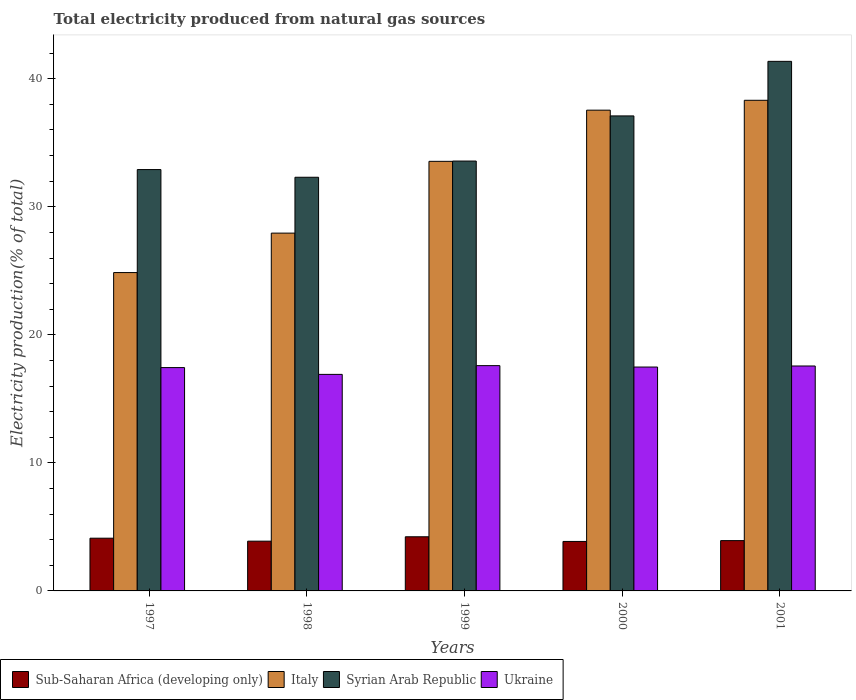How many different coloured bars are there?
Make the answer very short. 4. Are the number of bars per tick equal to the number of legend labels?
Your response must be concise. Yes. Are the number of bars on each tick of the X-axis equal?
Make the answer very short. Yes. In how many cases, is the number of bars for a given year not equal to the number of legend labels?
Provide a short and direct response. 0. What is the total electricity produced in Sub-Saharan Africa (developing only) in 2001?
Provide a short and direct response. 3.93. Across all years, what is the maximum total electricity produced in Syrian Arab Republic?
Offer a very short reply. 41.36. Across all years, what is the minimum total electricity produced in Sub-Saharan Africa (developing only)?
Ensure brevity in your answer.  3.86. In which year was the total electricity produced in Sub-Saharan Africa (developing only) maximum?
Your response must be concise. 1999. What is the total total electricity produced in Ukraine in the graph?
Give a very brief answer. 87. What is the difference between the total electricity produced in Ukraine in 1998 and that in 2001?
Provide a short and direct response. -0.66. What is the difference between the total electricity produced in Syrian Arab Republic in 1998 and the total electricity produced in Ukraine in 2001?
Offer a very short reply. 14.74. What is the average total electricity produced in Syrian Arab Republic per year?
Give a very brief answer. 35.45. In the year 2000, what is the difference between the total electricity produced in Sub-Saharan Africa (developing only) and total electricity produced in Italy?
Offer a very short reply. -33.68. What is the ratio of the total electricity produced in Syrian Arab Republic in 1999 to that in 2001?
Provide a succinct answer. 0.81. Is the difference between the total electricity produced in Sub-Saharan Africa (developing only) in 1997 and 2001 greater than the difference between the total electricity produced in Italy in 1997 and 2001?
Ensure brevity in your answer.  Yes. What is the difference between the highest and the second highest total electricity produced in Ukraine?
Make the answer very short. 0.03. What is the difference between the highest and the lowest total electricity produced in Ukraine?
Your answer should be very brief. 0.68. In how many years, is the total electricity produced in Italy greater than the average total electricity produced in Italy taken over all years?
Your answer should be very brief. 3. Is the sum of the total electricity produced in Italy in 1997 and 1998 greater than the maximum total electricity produced in Ukraine across all years?
Provide a short and direct response. Yes. Is it the case that in every year, the sum of the total electricity produced in Ukraine and total electricity produced in Syrian Arab Republic is greater than the sum of total electricity produced in Sub-Saharan Africa (developing only) and total electricity produced in Italy?
Keep it short and to the point. No. What does the 3rd bar from the right in 1997 represents?
Give a very brief answer. Italy. Is it the case that in every year, the sum of the total electricity produced in Italy and total electricity produced in Sub-Saharan Africa (developing only) is greater than the total electricity produced in Ukraine?
Keep it short and to the point. Yes. How many bars are there?
Give a very brief answer. 20. Are all the bars in the graph horizontal?
Offer a terse response. No. Are the values on the major ticks of Y-axis written in scientific E-notation?
Ensure brevity in your answer.  No. Does the graph contain any zero values?
Your response must be concise. No. Where does the legend appear in the graph?
Offer a very short reply. Bottom left. How many legend labels are there?
Give a very brief answer. 4. How are the legend labels stacked?
Provide a succinct answer. Horizontal. What is the title of the graph?
Give a very brief answer. Total electricity produced from natural gas sources. Does "Rwanda" appear as one of the legend labels in the graph?
Your response must be concise. No. What is the label or title of the Y-axis?
Make the answer very short. Electricity production(% of total). What is the Electricity production(% of total) of Sub-Saharan Africa (developing only) in 1997?
Ensure brevity in your answer.  4.12. What is the Electricity production(% of total) in Italy in 1997?
Make the answer very short. 24.86. What is the Electricity production(% of total) in Syrian Arab Republic in 1997?
Your response must be concise. 32.91. What is the Electricity production(% of total) of Ukraine in 1997?
Your answer should be very brief. 17.44. What is the Electricity production(% of total) of Sub-Saharan Africa (developing only) in 1998?
Provide a succinct answer. 3.89. What is the Electricity production(% of total) in Italy in 1998?
Offer a very short reply. 27.94. What is the Electricity production(% of total) in Syrian Arab Republic in 1998?
Offer a very short reply. 32.31. What is the Electricity production(% of total) in Ukraine in 1998?
Give a very brief answer. 16.91. What is the Electricity production(% of total) in Sub-Saharan Africa (developing only) in 1999?
Provide a short and direct response. 4.23. What is the Electricity production(% of total) in Italy in 1999?
Provide a short and direct response. 33.55. What is the Electricity production(% of total) of Syrian Arab Republic in 1999?
Your answer should be very brief. 33.57. What is the Electricity production(% of total) in Ukraine in 1999?
Provide a short and direct response. 17.6. What is the Electricity production(% of total) in Sub-Saharan Africa (developing only) in 2000?
Give a very brief answer. 3.86. What is the Electricity production(% of total) of Italy in 2000?
Provide a short and direct response. 37.55. What is the Electricity production(% of total) of Syrian Arab Republic in 2000?
Provide a succinct answer. 37.1. What is the Electricity production(% of total) of Ukraine in 2000?
Give a very brief answer. 17.49. What is the Electricity production(% of total) of Sub-Saharan Africa (developing only) in 2001?
Make the answer very short. 3.93. What is the Electricity production(% of total) of Italy in 2001?
Keep it short and to the point. 38.32. What is the Electricity production(% of total) of Syrian Arab Republic in 2001?
Offer a terse response. 41.36. What is the Electricity production(% of total) of Ukraine in 2001?
Make the answer very short. 17.57. Across all years, what is the maximum Electricity production(% of total) in Sub-Saharan Africa (developing only)?
Your response must be concise. 4.23. Across all years, what is the maximum Electricity production(% of total) of Italy?
Your response must be concise. 38.32. Across all years, what is the maximum Electricity production(% of total) in Syrian Arab Republic?
Your answer should be compact. 41.36. Across all years, what is the maximum Electricity production(% of total) in Ukraine?
Your answer should be compact. 17.6. Across all years, what is the minimum Electricity production(% of total) of Sub-Saharan Africa (developing only)?
Your answer should be compact. 3.86. Across all years, what is the minimum Electricity production(% of total) of Italy?
Provide a succinct answer. 24.86. Across all years, what is the minimum Electricity production(% of total) of Syrian Arab Republic?
Provide a succinct answer. 32.31. Across all years, what is the minimum Electricity production(% of total) of Ukraine?
Offer a terse response. 16.91. What is the total Electricity production(% of total) of Sub-Saharan Africa (developing only) in the graph?
Your answer should be compact. 20.03. What is the total Electricity production(% of total) of Italy in the graph?
Give a very brief answer. 162.23. What is the total Electricity production(% of total) of Syrian Arab Republic in the graph?
Your answer should be very brief. 177.25. What is the total Electricity production(% of total) in Ukraine in the graph?
Your response must be concise. 87. What is the difference between the Electricity production(% of total) of Sub-Saharan Africa (developing only) in 1997 and that in 1998?
Your answer should be compact. 0.23. What is the difference between the Electricity production(% of total) in Italy in 1997 and that in 1998?
Offer a terse response. -3.08. What is the difference between the Electricity production(% of total) in Syrian Arab Republic in 1997 and that in 1998?
Keep it short and to the point. 0.6. What is the difference between the Electricity production(% of total) in Ukraine in 1997 and that in 1998?
Offer a very short reply. 0.53. What is the difference between the Electricity production(% of total) in Sub-Saharan Africa (developing only) in 1997 and that in 1999?
Give a very brief answer. -0.11. What is the difference between the Electricity production(% of total) of Italy in 1997 and that in 1999?
Provide a short and direct response. -8.69. What is the difference between the Electricity production(% of total) of Syrian Arab Republic in 1997 and that in 1999?
Your answer should be very brief. -0.66. What is the difference between the Electricity production(% of total) of Ukraine in 1997 and that in 1999?
Offer a terse response. -0.15. What is the difference between the Electricity production(% of total) in Sub-Saharan Africa (developing only) in 1997 and that in 2000?
Give a very brief answer. 0.25. What is the difference between the Electricity production(% of total) of Italy in 1997 and that in 2000?
Your response must be concise. -12.68. What is the difference between the Electricity production(% of total) in Syrian Arab Republic in 1997 and that in 2000?
Offer a terse response. -4.19. What is the difference between the Electricity production(% of total) of Ukraine in 1997 and that in 2000?
Offer a terse response. -0.04. What is the difference between the Electricity production(% of total) of Sub-Saharan Africa (developing only) in 1997 and that in 2001?
Your answer should be compact. 0.19. What is the difference between the Electricity production(% of total) in Italy in 1997 and that in 2001?
Provide a short and direct response. -13.46. What is the difference between the Electricity production(% of total) in Syrian Arab Republic in 1997 and that in 2001?
Offer a terse response. -8.45. What is the difference between the Electricity production(% of total) of Ukraine in 1997 and that in 2001?
Provide a short and direct response. -0.13. What is the difference between the Electricity production(% of total) in Sub-Saharan Africa (developing only) in 1998 and that in 1999?
Provide a short and direct response. -0.34. What is the difference between the Electricity production(% of total) in Italy in 1998 and that in 1999?
Offer a terse response. -5.61. What is the difference between the Electricity production(% of total) of Syrian Arab Republic in 1998 and that in 1999?
Provide a short and direct response. -1.27. What is the difference between the Electricity production(% of total) of Ukraine in 1998 and that in 1999?
Your answer should be very brief. -0.68. What is the difference between the Electricity production(% of total) of Sub-Saharan Africa (developing only) in 1998 and that in 2000?
Make the answer very short. 0.02. What is the difference between the Electricity production(% of total) of Italy in 1998 and that in 2000?
Keep it short and to the point. -9.6. What is the difference between the Electricity production(% of total) in Syrian Arab Republic in 1998 and that in 2000?
Give a very brief answer. -4.79. What is the difference between the Electricity production(% of total) of Ukraine in 1998 and that in 2000?
Your response must be concise. -0.57. What is the difference between the Electricity production(% of total) of Sub-Saharan Africa (developing only) in 1998 and that in 2001?
Ensure brevity in your answer.  -0.04. What is the difference between the Electricity production(% of total) of Italy in 1998 and that in 2001?
Provide a short and direct response. -10.37. What is the difference between the Electricity production(% of total) of Syrian Arab Republic in 1998 and that in 2001?
Your response must be concise. -9.05. What is the difference between the Electricity production(% of total) of Ukraine in 1998 and that in 2001?
Ensure brevity in your answer.  -0.66. What is the difference between the Electricity production(% of total) in Sub-Saharan Africa (developing only) in 1999 and that in 2000?
Provide a short and direct response. 0.37. What is the difference between the Electricity production(% of total) in Italy in 1999 and that in 2000?
Your response must be concise. -4. What is the difference between the Electricity production(% of total) of Syrian Arab Republic in 1999 and that in 2000?
Keep it short and to the point. -3.53. What is the difference between the Electricity production(% of total) of Ukraine in 1999 and that in 2000?
Make the answer very short. 0.11. What is the difference between the Electricity production(% of total) of Sub-Saharan Africa (developing only) in 1999 and that in 2001?
Ensure brevity in your answer.  0.3. What is the difference between the Electricity production(% of total) in Italy in 1999 and that in 2001?
Provide a succinct answer. -4.77. What is the difference between the Electricity production(% of total) in Syrian Arab Republic in 1999 and that in 2001?
Your answer should be compact. -7.79. What is the difference between the Electricity production(% of total) in Ukraine in 1999 and that in 2001?
Make the answer very short. 0.03. What is the difference between the Electricity production(% of total) of Sub-Saharan Africa (developing only) in 2000 and that in 2001?
Offer a terse response. -0.07. What is the difference between the Electricity production(% of total) of Italy in 2000 and that in 2001?
Give a very brief answer. -0.77. What is the difference between the Electricity production(% of total) in Syrian Arab Republic in 2000 and that in 2001?
Your answer should be compact. -4.26. What is the difference between the Electricity production(% of total) in Ukraine in 2000 and that in 2001?
Make the answer very short. -0.08. What is the difference between the Electricity production(% of total) in Sub-Saharan Africa (developing only) in 1997 and the Electricity production(% of total) in Italy in 1998?
Provide a succinct answer. -23.83. What is the difference between the Electricity production(% of total) in Sub-Saharan Africa (developing only) in 1997 and the Electricity production(% of total) in Syrian Arab Republic in 1998?
Ensure brevity in your answer.  -28.19. What is the difference between the Electricity production(% of total) in Sub-Saharan Africa (developing only) in 1997 and the Electricity production(% of total) in Ukraine in 1998?
Your answer should be compact. -12.79. What is the difference between the Electricity production(% of total) of Italy in 1997 and the Electricity production(% of total) of Syrian Arab Republic in 1998?
Ensure brevity in your answer.  -7.44. What is the difference between the Electricity production(% of total) of Italy in 1997 and the Electricity production(% of total) of Ukraine in 1998?
Make the answer very short. 7.95. What is the difference between the Electricity production(% of total) in Syrian Arab Republic in 1997 and the Electricity production(% of total) in Ukraine in 1998?
Offer a terse response. 16. What is the difference between the Electricity production(% of total) in Sub-Saharan Africa (developing only) in 1997 and the Electricity production(% of total) in Italy in 1999?
Your answer should be compact. -29.43. What is the difference between the Electricity production(% of total) in Sub-Saharan Africa (developing only) in 1997 and the Electricity production(% of total) in Syrian Arab Republic in 1999?
Your response must be concise. -29.45. What is the difference between the Electricity production(% of total) in Sub-Saharan Africa (developing only) in 1997 and the Electricity production(% of total) in Ukraine in 1999?
Provide a short and direct response. -13.48. What is the difference between the Electricity production(% of total) in Italy in 1997 and the Electricity production(% of total) in Syrian Arab Republic in 1999?
Give a very brief answer. -8.71. What is the difference between the Electricity production(% of total) in Italy in 1997 and the Electricity production(% of total) in Ukraine in 1999?
Keep it short and to the point. 7.27. What is the difference between the Electricity production(% of total) of Syrian Arab Republic in 1997 and the Electricity production(% of total) of Ukraine in 1999?
Provide a short and direct response. 15.31. What is the difference between the Electricity production(% of total) of Sub-Saharan Africa (developing only) in 1997 and the Electricity production(% of total) of Italy in 2000?
Provide a short and direct response. -33.43. What is the difference between the Electricity production(% of total) in Sub-Saharan Africa (developing only) in 1997 and the Electricity production(% of total) in Syrian Arab Republic in 2000?
Make the answer very short. -32.98. What is the difference between the Electricity production(% of total) in Sub-Saharan Africa (developing only) in 1997 and the Electricity production(% of total) in Ukraine in 2000?
Make the answer very short. -13.37. What is the difference between the Electricity production(% of total) of Italy in 1997 and the Electricity production(% of total) of Syrian Arab Republic in 2000?
Keep it short and to the point. -12.24. What is the difference between the Electricity production(% of total) in Italy in 1997 and the Electricity production(% of total) in Ukraine in 2000?
Your answer should be very brief. 7.38. What is the difference between the Electricity production(% of total) of Syrian Arab Republic in 1997 and the Electricity production(% of total) of Ukraine in 2000?
Ensure brevity in your answer.  15.42. What is the difference between the Electricity production(% of total) of Sub-Saharan Africa (developing only) in 1997 and the Electricity production(% of total) of Italy in 2001?
Provide a short and direct response. -34.2. What is the difference between the Electricity production(% of total) in Sub-Saharan Africa (developing only) in 1997 and the Electricity production(% of total) in Syrian Arab Republic in 2001?
Ensure brevity in your answer.  -37.24. What is the difference between the Electricity production(% of total) of Sub-Saharan Africa (developing only) in 1997 and the Electricity production(% of total) of Ukraine in 2001?
Your response must be concise. -13.45. What is the difference between the Electricity production(% of total) of Italy in 1997 and the Electricity production(% of total) of Syrian Arab Republic in 2001?
Ensure brevity in your answer.  -16.5. What is the difference between the Electricity production(% of total) in Italy in 1997 and the Electricity production(% of total) in Ukraine in 2001?
Make the answer very short. 7.3. What is the difference between the Electricity production(% of total) in Syrian Arab Republic in 1997 and the Electricity production(% of total) in Ukraine in 2001?
Ensure brevity in your answer.  15.34. What is the difference between the Electricity production(% of total) in Sub-Saharan Africa (developing only) in 1998 and the Electricity production(% of total) in Italy in 1999?
Give a very brief answer. -29.66. What is the difference between the Electricity production(% of total) in Sub-Saharan Africa (developing only) in 1998 and the Electricity production(% of total) in Syrian Arab Republic in 1999?
Offer a terse response. -29.69. What is the difference between the Electricity production(% of total) of Sub-Saharan Africa (developing only) in 1998 and the Electricity production(% of total) of Ukraine in 1999?
Offer a terse response. -13.71. What is the difference between the Electricity production(% of total) of Italy in 1998 and the Electricity production(% of total) of Syrian Arab Republic in 1999?
Offer a very short reply. -5.63. What is the difference between the Electricity production(% of total) of Italy in 1998 and the Electricity production(% of total) of Ukraine in 1999?
Offer a very short reply. 10.35. What is the difference between the Electricity production(% of total) in Syrian Arab Republic in 1998 and the Electricity production(% of total) in Ukraine in 1999?
Give a very brief answer. 14.71. What is the difference between the Electricity production(% of total) in Sub-Saharan Africa (developing only) in 1998 and the Electricity production(% of total) in Italy in 2000?
Keep it short and to the point. -33.66. What is the difference between the Electricity production(% of total) of Sub-Saharan Africa (developing only) in 1998 and the Electricity production(% of total) of Syrian Arab Republic in 2000?
Provide a short and direct response. -33.21. What is the difference between the Electricity production(% of total) of Sub-Saharan Africa (developing only) in 1998 and the Electricity production(% of total) of Ukraine in 2000?
Make the answer very short. -13.6. What is the difference between the Electricity production(% of total) of Italy in 1998 and the Electricity production(% of total) of Syrian Arab Republic in 2000?
Offer a terse response. -9.15. What is the difference between the Electricity production(% of total) in Italy in 1998 and the Electricity production(% of total) in Ukraine in 2000?
Provide a short and direct response. 10.46. What is the difference between the Electricity production(% of total) in Syrian Arab Republic in 1998 and the Electricity production(% of total) in Ukraine in 2000?
Keep it short and to the point. 14.82. What is the difference between the Electricity production(% of total) in Sub-Saharan Africa (developing only) in 1998 and the Electricity production(% of total) in Italy in 2001?
Provide a short and direct response. -34.43. What is the difference between the Electricity production(% of total) of Sub-Saharan Africa (developing only) in 1998 and the Electricity production(% of total) of Syrian Arab Republic in 2001?
Give a very brief answer. -37.47. What is the difference between the Electricity production(% of total) in Sub-Saharan Africa (developing only) in 1998 and the Electricity production(% of total) in Ukraine in 2001?
Offer a very short reply. -13.68. What is the difference between the Electricity production(% of total) of Italy in 1998 and the Electricity production(% of total) of Syrian Arab Republic in 2001?
Your response must be concise. -13.41. What is the difference between the Electricity production(% of total) in Italy in 1998 and the Electricity production(% of total) in Ukraine in 2001?
Make the answer very short. 10.38. What is the difference between the Electricity production(% of total) in Syrian Arab Republic in 1998 and the Electricity production(% of total) in Ukraine in 2001?
Your response must be concise. 14.74. What is the difference between the Electricity production(% of total) in Sub-Saharan Africa (developing only) in 1999 and the Electricity production(% of total) in Italy in 2000?
Give a very brief answer. -33.32. What is the difference between the Electricity production(% of total) in Sub-Saharan Africa (developing only) in 1999 and the Electricity production(% of total) in Syrian Arab Republic in 2000?
Offer a terse response. -32.87. What is the difference between the Electricity production(% of total) in Sub-Saharan Africa (developing only) in 1999 and the Electricity production(% of total) in Ukraine in 2000?
Provide a succinct answer. -13.26. What is the difference between the Electricity production(% of total) in Italy in 1999 and the Electricity production(% of total) in Syrian Arab Republic in 2000?
Your answer should be compact. -3.55. What is the difference between the Electricity production(% of total) in Italy in 1999 and the Electricity production(% of total) in Ukraine in 2000?
Ensure brevity in your answer.  16.07. What is the difference between the Electricity production(% of total) of Syrian Arab Republic in 1999 and the Electricity production(% of total) of Ukraine in 2000?
Offer a very short reply. 16.09. What is the difference between the Electricity production(% of total) of Sub-Saharan Africa (developing only) in 1999 and the Electricity production(% of total) of Italy in 2001?
Your answer should be very brief. -34.09. What is the difference between the Electricity production(% of total) in Sub-Saharan Africa (developing only) in 1999 and the Electricity production(% of total) in Syrian Arab Republic in 2001?
Provide a succinct answer. -37.13. What is the difference between the Electricity production(% of total) in Sub-Saharan Africa (developing only) in 1999 and the Electricity production(% of total) in Ukraine in 2001?
Make the answer very short. -13.34. What is the difference between the Electricity production(% of total) of Italy in 1999 and the Electricity production(% of total) of Syrian Arab Republic in 2001?
Provide a succinct answer. -7.81. What is the difference between the Electricity production(% of total) in Italy in 1999 and the Electricity production(% of total) in Ukraine in 2001?
Your response must be concise. 15.98. What is the difference between the Electricity production(% of total) of Syrian Arab Republic in 1999 and the Electricity production(% of total) of Ukraine in 2001?
Your answer should be very brief. 16.01. What is the difference between the Electricity production(% of total) in Sub-Saharan Africa (developing only) in 2000 and the Electricity production(% of total) in Italy in 2001?
Your answer should be very brief. -34.46. What is the difference between the Electricity production(% of total) of Sub-Saharan Africa (developing only) in 2000 and the Electricity production(% of total) of Syrian Arab Republic in 2001?
Offer a terse response. -37.5. What is the difference between the Electricity production(% of total) of Sub-Saharan Africa (developing only) in 2000 and the Electricity production(% of total) of Ukraine in 2001?
Your answer should be very brief. -13.7. What is the difference between the Electricity production(% of total) in Italy in 2000 and the Electricity production(% of total) in Syrian Arab Republic in 2001?
Give a very brief answer. -3.81. What is the difference between the Electricity production(% of total) in Italy in 2000 and the Electricity production(% of total) in Ukraine in 2001?
Your answer should be compact. 19.98. What is the difference between the Electricity production(% of total) of Syrian Arab Republic in 2000 and the Electricity production(% of total) of Ukraine in 2001?
Ensure brevity in your answer.  19.53. What is the average Electricity production(% of total) in Sub-Saharan Africa (developing only) per year?
Your answer should be very brief. 4.01. What is the average Electricity production(% of total) of Italy per year?
Give a very brief answer. 32.45. What is the average Electricity production(% of total) in Syrian Arab Republic per year?
Provide a succinct answer. 35.45. What is the average Electricity production(% of total) in Ukraine per year?
Provide a succinct answer. 17.4. In the year 1997, what is the difference between the Electricity production(% of total) in Sub-Saharan Africa (developing only) and Electricity production(% of total) in Italy?
Keep it short and to the point. -20.74. In the year 1997, what is the difference between the Electricity production(% of total) of Sub-Saharan Africa (developing only) and Electricity production(% of total) of Syrian Arab Republic?
Provide a short and direct response. -28.79. In the year 1997, what is the difference between the Electricity production(% of total) in Sub-Saharan Africa (developing only) and Electricity production(% of total) in Ukraine?
Offer a terse response. -13.32. In the year 1997, what is the difference between the Electricity production(% of total) in Italy and Electricity production(% of total) in Syrian Arab Republic?
Provide a short and direct response. -8.05. In the year 1997, what is the difference between the Electricity production(% of total) of Italy and Electricity production(% of total) of Ukraine?
Your response must be concise. 7.42. In the year 1997, what is the difference between the Electricity production(% of total) of Syrian Arab Republic and Electricity production(% of total) of Ukraine?
Your response must be concise. 15.47. In the year 1998, what is the difference between the Electricity production(% of total) in Sub-Saharan Africa (developing only) and Electricity production(% of total) in Italy?
Ensure brevity in your answer.  -24.06. In the year 1998, what is the difference between the Electricity production(% of total) of Sub-Saharan Africa (developing only) and Electricity production(% of total) of Syrian Arab Republic?
Make the answer very short. -28.42. In the year 1998, what is the difference between the Electricity production(% of total) of Sub-Saharan Africa (developing only) and Electricity production(% of total) of Ukraine?
Your response must be concise. -13.03. In the year 1998, what is the difference between the Electricity production(% of total) of Italy and Electricity production(% of total) of Syrian Arab Republic?
Ensure brevity in your answer.  -4.36. In the year 1998, what is the difference between the Electricity production(% of total) in Italy and Electricity production(% of total) in Ukraine?
Give a very brief answer. 11.03. In the year 1998, what is the difference between the Electricity production(% of total) of Syrian Arab Republic and Electricity production(% of total) of Ukraine?
Provide a succinct answer. 15.4. In the year 1999, what is the difference between the Electricity production(% of total) of Sub-Saharan Africa (developing only) and Electricity production(% of total) of Italy?
Your answer should be very brief. -29.32. In the year 1999, what is the difference between the Electricity production(% of total) of Sub-Saharan Africa (developing only) and Electricity production(% of total) of Syrian Arab Republic?
Your answer should be compact. -29.34. In the year 1999, what is the difference between the Electricity production(% of total) in Sub-Saharan Africa (developing only) and Electricity production(% of total) in Ukraine?
Give a very brief answer. -13.37. In the year 1999, what is the difference between the Electricity production(% of total) of Italy and Electricity production(% of total) of Syrian Arab Republic?
Offer a terse response. -0.02. In the year 1999, what is the difference between the Electricity production(% of total) of Italy and Electricity production(% of total) of Ukraine?
Provide a succinct answer. 15.96. In the year 1999, what is the difference between the Electricity production(% of total) in Syrian Arab Republic and Electricity production(% of total) in Ukraine?
Your response must be concise. 15.98. In the year 2000, what is the difference between the Electricity production(% of total) in Sub-Saharan Africa (developing only) and Electricity production(% of total) in Italy?
Your response must be concise. -33.68. In the year 2000, what is the difference between the Electricity production(% of total) of Sub-Saharan Africa (developing only) and Electricity production(% of total) of Syrian Arab Republic?
Provide a short and direct response. -33.23. In the year 2000, what is the difference between the Electricity production(% of total) in Sub-Saharan Africa (developing only) and Electricity production(% of total) in Ukraine?
Provide a succinct answer. -13.62. In the year 2000, what is the difference between the Electricity production(% of total) of Italy and Electricity production(% of total) of Syrian Arab Republic?
Your answer should be very brief. 0.45. In the year 2000, what is the difference between the Electricity production(% of total) in Italy and Electricity production(% of total) in Ukraine?
Provide a short and direct response. 20.06. In the year 2000, what is the difference between the Electricity production(% of total) of Syrian Arab Republic and Electricity production(% of total) of Ukraine?
Ensure brevity in your answer.  19.61. In the year 2001, what is the difference between the Electricity production(% of total) in Sub-Saharan Africa (developing only) and Electricity production(% of total) in Italy?
Make the answer very short. -34.39. In the year 2001, what is the difference between the Electricity production(% of total) of Sub-Saharan Africa (developing only) and Electricity production(% of total) of Syrian Arab Republic?
Give a very brief answer. -37.43. In the year 2001, what is the difference between the Electricity production(% of total) in Sub-Saharan Africa (developing only) and Electricity production(% of total) in Ukraine?
Keep it short and to the point. -13.64. In the year 2001, what is the difference between the Electricity production(% of total) in Italy and Electricity production(% of total) in Syrian Arab Republic?
Offer a very short reply. -3.04. In the year 2001, what is the difference between the Electricity production(% of total) in Italy and Electricity production(% of total) in Ukraine?
Give a very brief answer. 20.75. In the year 2001, what is the difference between the Electricity production(% of total) in Syrian Arab Republic and Electricity production(% of total) in Ukraine?
Your answer should be very brief. 23.79. What is the ratio of the Electricity production(% of total) in Sub-Saharan Africa (developing only) in 1997 to that in 1998?
Offer a terse response. 1.06. What is the ratio of the Electricity production(% of total) of Italy in 1997 to that in 1998?
Your answer should be compact. 0.89. What is the ratio of the Electricity production(% of total) of Syrian Arab Republic in 1997 to that in 1998?
Provide a succinct answer. 1.02. What is the ratio of the Electricity production(% of total) of Ukraine in 1997 to that in 1998?
Provide a succinct answer. 1.03. What is the ratio of the Electricity production(% of total) in Sub-Saharan Africa (developing only) in 1997 to that in 1999?
Keep it short and to the point. 0.97. What is the ratio of the Electricity production(% of total) of Italy in 1997 to that in 1999?
Give a very brief answer. 0.74. What is the ratio of the Electricity production(% of total) in Syrian Arab Republic in 1997 to that in 1999?
Your response must be concise. 0.98. What is the ratio of the Electricity production(% of total) of Ukraine in 1997 to that in 1999?
Offer a very short reply. 0.99. What is the ratio of the Electricity production(% of total) of Sub-Saharan Africa (developing only) in 1997 to that in 2000?
Make the answer very short. 1.07. What is the ratio of the Electricity production(% of total) of Italy in 1997 to that in 2000?
Provide a short and direct response. 0.66. What is the ratio of the Electricity production(% of total) of Syrian Arab Republic in 1997 to that in 2000?
Provide a succinct answer. 0.89. What is the ratio of the Electricity production(% of total) in Ukraine in 1997 to that in 2000?
Keep it short and to the point. 1. What is the ratio of the Electricity production(% of total) of Sub-Saharan Africa (developing only) in 1997 to that in 2001?
Your answer should be very brief. 1.05. What is the ratio of the Electricity production(% of total) in Italy in 1997 to that in 2001?
Your response must be concise. 0.65. What is the ratio of the Electricity production(% of total) of Syrian Arab Republic in 1997 to that in 2001?
Keep it short and to the point. 0.8. What is the ratio of the Electricity production(% of total) of Ukraine in 1997 to that in 2001?
Offer a very short reply. 0.99. What is the ratio of the Electricity production(% of total) of Sub-Saharan Africa (developing only) in 1998 to that in 1999?
Give a very brief answer. 0.92. What is the ratio of the Electricity production(% of total) in Italy in 1998 to that in 1999?
Offer a terse response. 0.83. What is the ratio of the Electricity production(% of total) of Syrian Arab Republic in 1998 to that in 1999?
Provide a succinct answer. 0.96. What is the ratio of the Electricity production(% of total) in Ukraine in 1998 to that in 1999?
Your response must be concise. 0.96. What is the ratio of the Electricity production(% of total) in Italy in 1998 to that in 2000?
Your answer should be compact. 0.74. What is the ratio of the Electricity production(% of total) of Syrian Arab Republic in 1998 to that in 2000?
Provide a short and direct response. 0.87. What is the ratio of the Electricity production(% of total) in Ukraine in 1998 to that in 2000?
Your answer should be compact. 0.97. What is the ratio of the Electricity production(% of total) of Italy in 1998 to that in 2001?
Offer a terse response. 0.73. What is the ratio of the Electricity production(% of total) in Syrian Arab Republic in 1998 to that in 2001?
Your response must be concise. 0.78. What is the ratio of the Electricity production(% of total) of Ukraine in 1998 to that in 2001?
Keep it short and to the point. 0.96. What is the ratio of the Electricity production(% of total) in Sub-Saharan Africa (developing only) in 1999 to that in 2000?
Your response must be concise. 1.09. What is the ratio of the Electricity production(% of total) in Italy in 1999 to that in 2000?
Give a very brief answer. 0.89. What is the ratio of the Electricity production(% of total) in Syrian Arab Republic in 1999 to that in 2000?
Give a very brief answer. 0.91. What is the ratio of the Electricity production(% of total) in Sub-Saharan Africa (developing only) in 1999 to that in 2001?
Give a very brief answer. 1.08. What is the ratio of the Electricity production(% of total) in Italy in 1999 to that in 2001?
Ensure brevity in your answer.  0.88. What is the ratio of the Electricity production(% of total) of Syrian Arab Republic in 1999 to that in 2001?
Provide a succinct answer. 0.81. What is the ratio of the Electricity production(% of total) in Sub-Saharan Africa (developing only) in 2000 to that in 2001?
Offer a very short reply. 0.98. What is the ratio of the Electricity production(% of total) of Italy in 2000 to that in 2001?
Ensure brevity in your answer.  0.98. What is the ratio of the Electricity production(% of total) of Syrian Arab Republic in 2000 to that in 2001?
Your answer should be compact. 0.9. What is the ratio of the Electricity production(% of total) in Ukraine in 2000 to that in 2001?
Provide a succinct answer. 1. What is the difference between the highest and the second highest Electricity production(% of total) in Sub-Saharan Africa (developing only)?
Your answer should be very brief. 0.11. What is the difference between the highest and the second highest Electricity production(% of total) of Italy?
Your answer should be very brief. 0.77. What is the difference between the highest and the second highest Electricity production(% of total) in Syrian Arab Republic?
Make the answer very short. 4.26. What is the difference between the highest and the second highest Electricity production(% of total) of Ukraine?
Offer a very short reply. 0.03. What is the difference between the highest and the lowest Electricity production(% of total) in Sub-Saharan Africa (developing only)?
Your answer should be compact. 0.37. What is the difference between the highest and the lowest Electricity production(% of total) in Italy?
Your response must be concise. 13.46. What is the difference between the highest and the lowest Electricity production(% of total) of Syrian Arab Republic?
Offer a terse response. 9.05. What is the difference between the highest and the lowest Electricity production(% of total) in Ukraine?
Give a very brief answer. 0.68. 